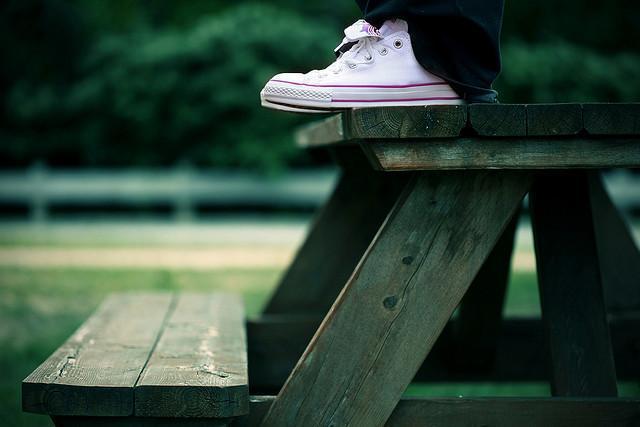How many horses are there?
Give a very brief answer. 0. 